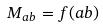Convert formula to latex. <formula><loc_0><loc_0><loc_500><loc_500>M _ { a b } = f ( a b )</formula> 